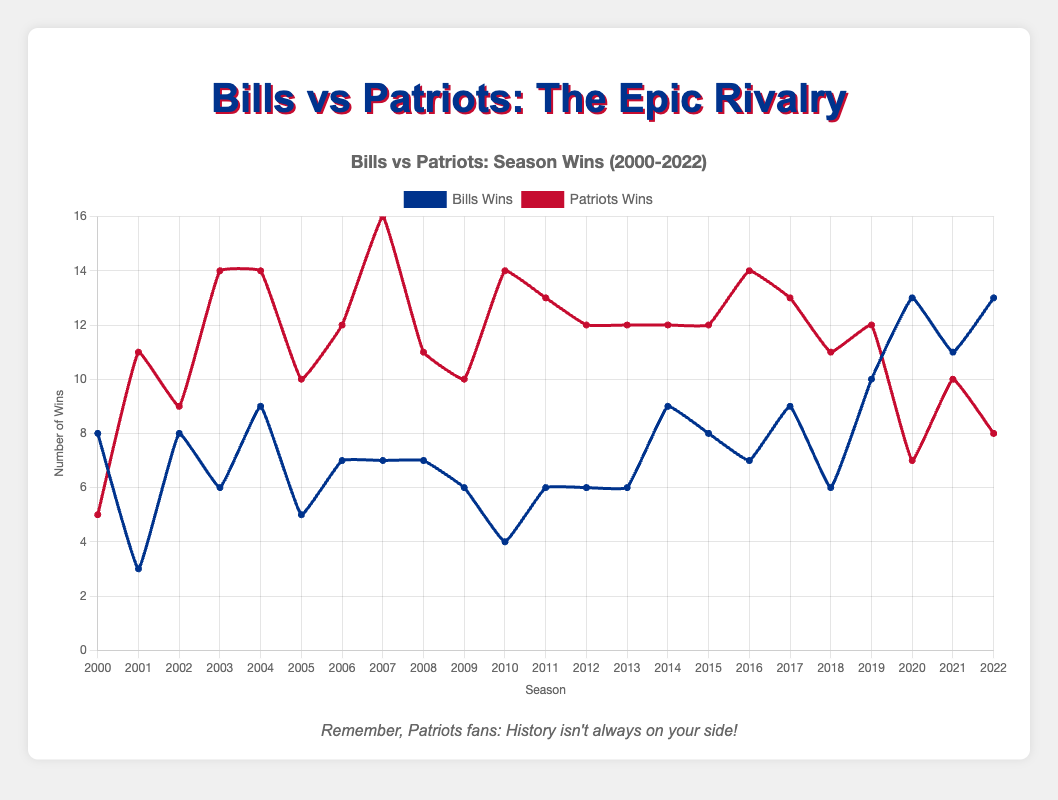When did the Bills first surpass the Patriots in wins? By observing the plot, the Bills first surpassed the Patriots in the 2020 season where the Bills had 13 wins compared to the Patriots' 7 wins.
Answer: 2020 In which years did the Bills have exactly the same number of wins as the Patriots? By looking at the plot, the Bills and Patriots had the same number of wins in the 2002 and 2021 seasons.
Answer: 2002, 2021 What's the total number of wins for the Bills from 2000 to 2022? Summing up the Bills' wins over the seasons from 2000 to 2022: 8+3+8+6+9+5+7+7+7+6+4+6+6+6+9+8+7+9+6+10+13+11+13 = 173
Answer: 173 How many seasons did the Patriots have more than 12 wins? By examining the plot, the Patriots had more than 12 wins in the seasons 2003, 2004, 2007, 2010, 2011, 2016, and 2017. This gives us 7 seasons.
Answer: 7 What is the difference in the total number of wins (from 2000 to 2022) between the Bills and the Patriots? Calculate the total wins for each team: Bills' total = 173, Patriots' total = 271. The difference is 271 - 173 = 98
Answer: 98 During which season did the Patriots have their highest win total, and how many wins was it? In the plot, the highest peak for the Patriots is in 2007, where they had 16 wins.
Answer: 2007, 16 Compare the 2017 season in terms of wins between the Bills and the Patriots. Which team performed better and by how many wins? In 2017, the Bills had 9 wins, and the Patriots had 13 wins, so the Patriots had 13 - 9 = 4 more wins than the Bills.
Answer: Patriots, 4 Which team's win record improved the most between the 2019 and 2020 seasons? From the plot, the Bills' wins increased from 10 in 2019 to 13 in 2020 (an increase of 3), whereas the Patriots' wins decreased from 12 in 2019 to 7 in 2020 (a decrease of 5).
Answer: Bills In how many seasons did the Bills have more than 8 wins? By observing the plot, the Bills had more than 8 wins in the seasons: 2004, 2019, 2020, 2021, 2022. This gives us 5 seasons.
Answer: 5 Visualize the win trend for both teams over the years. Based on the trend, which team's win pattern shows greater variation and why? By observing the ups and downs in the plot, the Patriots show a more consistent win pattern with years of high wins, whereas the Bills show a lot of variation with significant ups and downs over the seasons.
Answer: Bills 